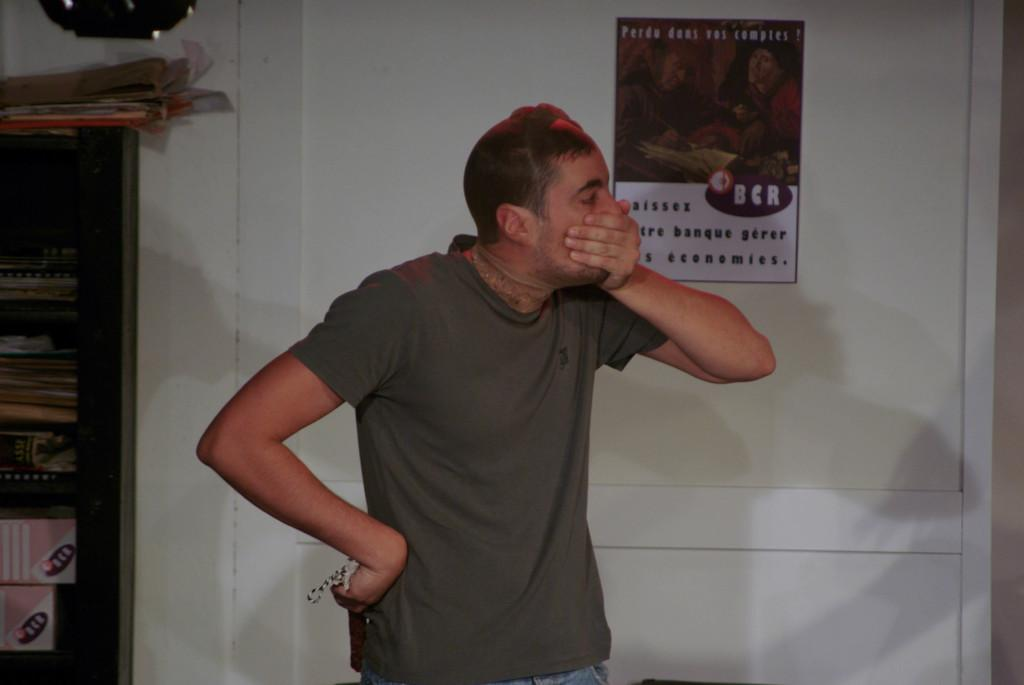<image>
Offer a succinct explanation of the picture presented. a poster that has the letters 'bcr' on it 